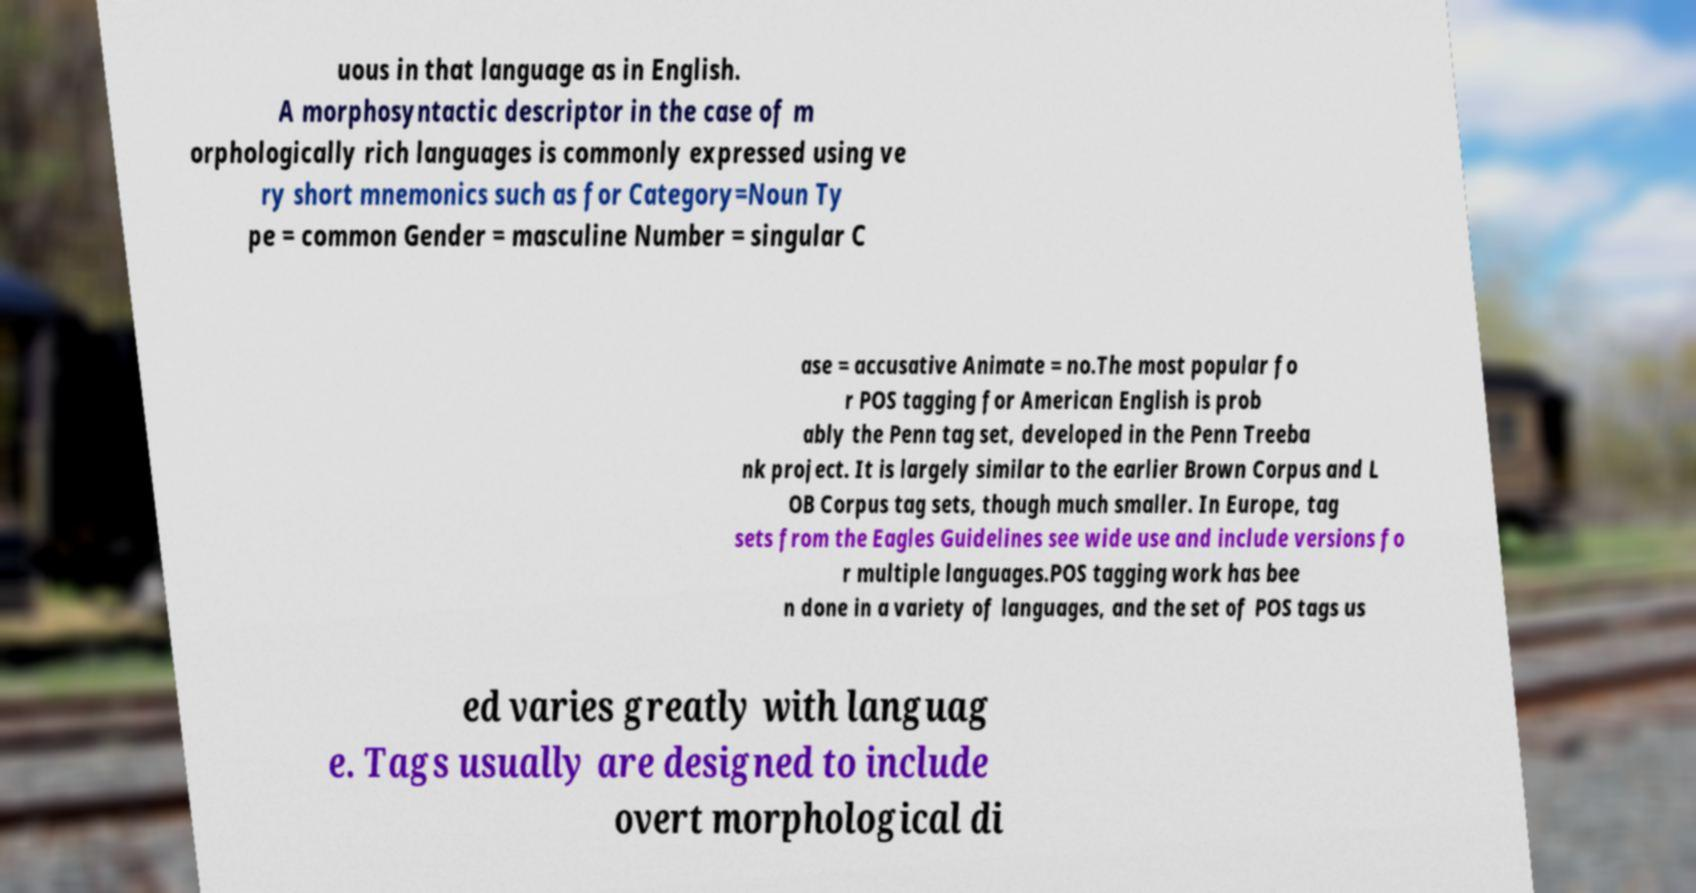Please identify and transcribe the text found in this image. uous in that language as in English. A morphosyntactic descriptor in the case of m orphologically rich languages is commonly expressed using ve ry short mnemonics such as for Category=Noun Ty pe = common Gender = masculine Number = singular C ase = accusative Animate = no.The most popular fo r POS tagging for American English is prob ably the Penn tag set, developed in the Penn Treeba nk project. It is largely similar to the earlier Brown Corpus and L OB Corpus tag sets, though much smaller. In Europe, tag sets from the Eagles Guidelines see wide use and include versions fo r multiple languages.POS tagging work has bee n done in a variety of languages, and the set of POS tags us ed varies greatly with languag e. Tags usually are designed to include overt morphological di 